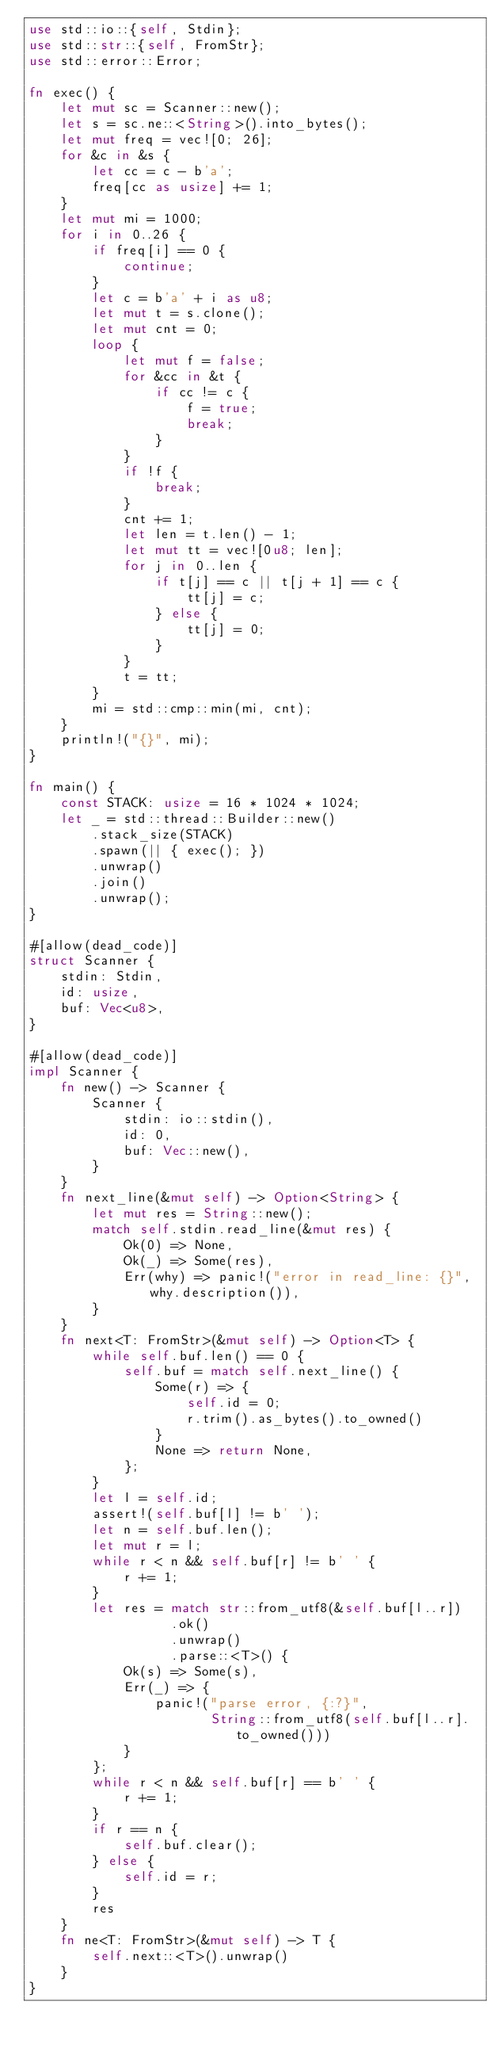<code> <loc_0><loc_0><loc_500><loc_500><_Rust_>use std::io::{self, Stdin};
use std::str::{self, FromStr};
use std::error::Error;

fn exec() {
    let mut sc = Scanner::new();
    let s = sc.ne::<String>().into_bytes();
    let mut freq = vec![0; 26];
    for &c in &s {
        let cc = c - b'a';
        freq[cc as usize] += 1;
    }
    let mut mi = 1000;
    for i in 0..26 {
        if freq[i] == 0 {
            continue;
        }
        let c = b'a' + i as u8;
        let mut t = s.clone();
        let mut cnt = 0;
        loop {
            let mut f = false;
            for &cc in &t {
                if cc != c {
                    f = true;
                    break;
                }
            }
            if !f {
                break;
            }
            cnt += 1;
            let len = t.len() - 1;
            let mut tt = vec![0u8; len];
            for j in 0..len {
                if t[j] == c || t[j + 1] == c {
                    tt[j] = c;
                } else {
                    tt[j] = 0;
                }
            }
            t = tt;
        }
        mi = std::cmp::min(mi, cnt);
    }
    println!("{}", mi);
}

fn main() {
    const STACK: usize = 16 * 1024 * 1024;
    let _ = std::thread::Builder::new()
        .stack_size(STACK)
        .spawn(|| { exec(); })
        .unwrap()
        .join()
        .unwrap();
}

#[allow(dead_code)]
struct Scanner {
    stdin: Stdin,
    id: usize,
    buf: Vec<u8>,
}

#[allow(dead_code)]
impl Scanner {
    fn new() -> Scanner {
        Scanner {
            stdin: io::stdin(),
            id: 0,
            buf: Vec::new(),
        }
    }
    fn next_line(&mut self) -> Option<String> {
        let mut res = String::new();
        match self.stdin.read_line(&mut res) {
            Ok(0) => None,
            Ok(_) => Some(res),
            Err(why) => panic!("error in read_line: {}", why.description()),
        }
    }
    fn next<T: FromStr>(&mut self) -> Option<T> {
        while self.buf.len() == 0 {
            self.buf = match self.next_line() {
                Some(r) => {
                    self.id = 0;
                    r.trim().as_bytes().to_owned()
                }
                None => return None,
            };
        }
        let l = self.id;
        assert!(self.buf[l] != b' ');
        let n = self.buf.len();
        let mut r = l;
        while r < n && self.buf[r] != b' ' {
            r += 1;
        }
        let res = match str::from_utf8(&self.buf[l..r])
                  .ok()
                  .unwrap()
                  .parse::<T>() {
            Ok(s) => Some(s),
            Err(_) => {
                panic!("parse error, {:?}",
                       String::from_utf8(self.buf[l..r].to_owned()))
            }
        };
        while r < n && self.buf[r] == b' ' {
            r += 1;
        }
        if r == n {
            self.buf.clear();
        } else {
            self.id = r;
        }
        res
    }
    fn ne<T: FromStr>(&mut self) -> T {
        self.next::<T>().unwrap()
    }
}
</code> 